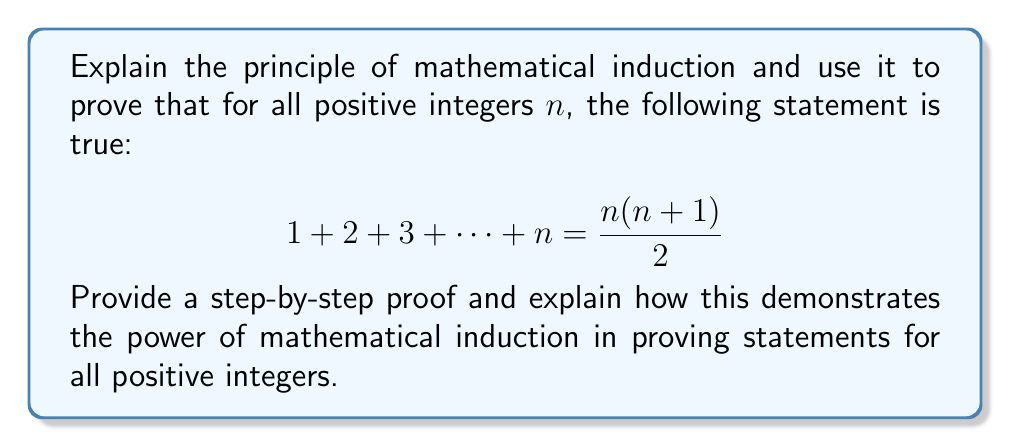Help me with this question. Mathematical induction is a powerful proof technique used to establish that a statement is true for all positive integers. It consists of two main steps:

1. Base case: Prove that the statement is true for the smallest value (usually n = 1).
2. Inductive step: Assume the statement is true for some arbitrary positive integer k (inductive hypothesis), then prove it's true for k + 1.

Let's apply this to prove the given statement:

$$ 1 + 2 + 3 + ... + n = \frac{n(n+1)}{2} $$

Step 1: Base case (n = 1)
For n = 1, the left side is simply 1.
The right side is $\frac{1(1+1)}{2} = \frac{2}{2} = 1$.
So, the statement is true for n = 1.

Step 2: Inductive step
Assume the statement is true for some positive integer k:
$$ 1 + 2 + 3 + ... + k = \frac{k(k+1)}{2} $$ (Inductive hypothesis)

Now, we need to prove it's true for k + 1:
$$ 1 + 2 + 3 + ... + k + (k+1) = \frac{(k+1)((k+1)+1)}{2} $$

Let's start with the left side:
$$ (1 + 2 + 3 + ... + k) + (k+1) $$

Using our inductive hypothesis, we can replace the part in parentheses:
$$ \frac{k(k+1)}{2} + (k+1) $$

Now, let's simplify:
$$ \frac{k(k+1)}{2} + \frac{2(k+1)}{2} = \frac{k(k+1) + 2(k+1)}{2} = \frac{(k+1)(k+2)}{2} $$

This is exactly the right side of our equation for k + 1, which completes the inductive step.

By the principle of mathematical induction, we have now proved that the statement is true for all positive integers n.

This example demonstrates the power of mathematical induction by allowing us to prove a statement for infinitely many cases using just two steps: a base case and an inductive step. It's particularly useful for statements involving sums, divisibility, or other properties that depend on previous terms.
Answer: The principle of mathematical induction is proved, and the statement $1 + 2 + 3 + ... + n = \frac{n(n+1)}{2}$ is true for all positive integers n. 